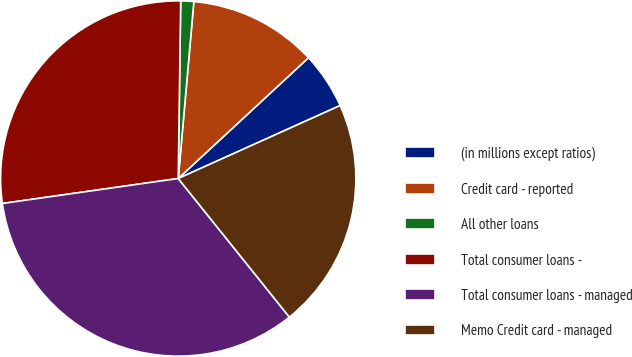Convert chart to OTSL. <chart><loc_0><loc_0><loc_500><loc_500><pie_chart><fcel>(in millions except ratios)<fcel>Credit card - reported<fcel>All other loans<fcel>Total consumer loans -<fcel>Total consumer loans - managed<fcel>Memo Credit card - managed<nl><fcel>5.16%<fcel>11.7%<fcel>1.18%<fcel>27.47%<fcel>33.51%<fcel>20.98%<nl></chart> 